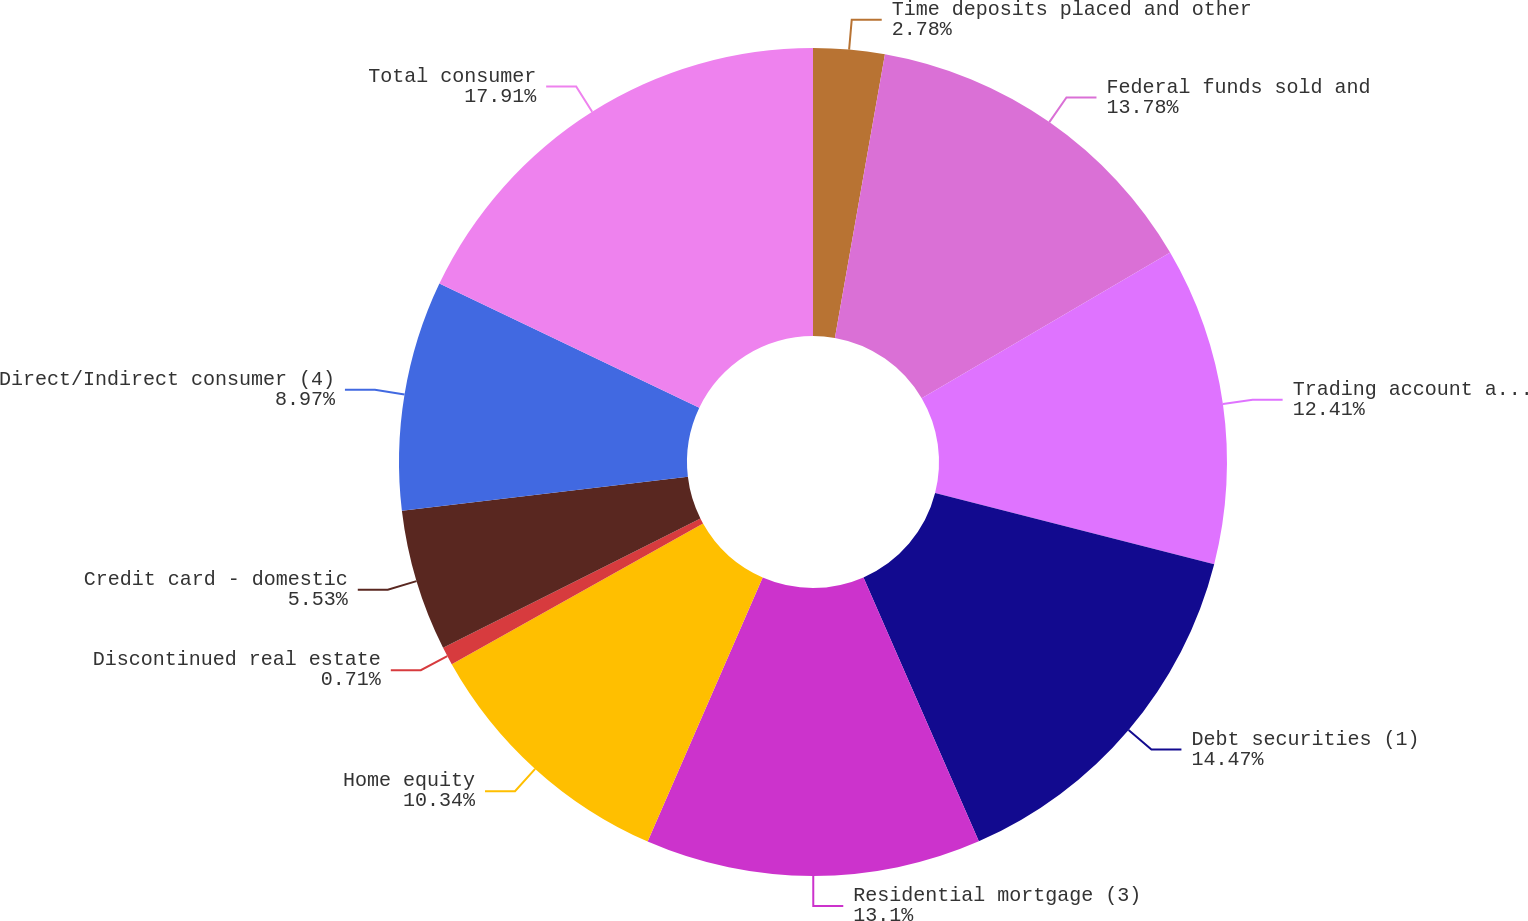Convert chart. <chart><loc_0><loc_0><loc_500><loc_500><pie_chart><fcel>Time deposits placed and other<fcel>Federal funds sold and<fcel>Trading account assets<fcel>Debt securities (1)<fcel>Residential mortgage (3)<fcel>Home equity<fcel>Discontinued real estate<fcel>Credit card - domestic<fcel>Direct/Indirect consumer (4)<fcel>Total consumer<nl><fcel>2.78%<fcel>13.78%<fcel>12.41%<fcel>14.47%<fcel>13.1%<fcel>10.34%<fcel>0.71%<fcel>5.53%<fcel>8.97%<fcel>17.91%<nl></chart> 